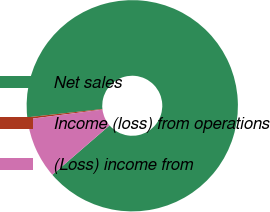<chart> <loc_0><loc_0><loc_500><loc_500><pie_chart><fcel>Net sales<fcel>Income (loss) from operations<fcel>(Loss) income from<nl><fcel>90.41%<fcel>0.29%<fcel>9.3%<nl></chart> 